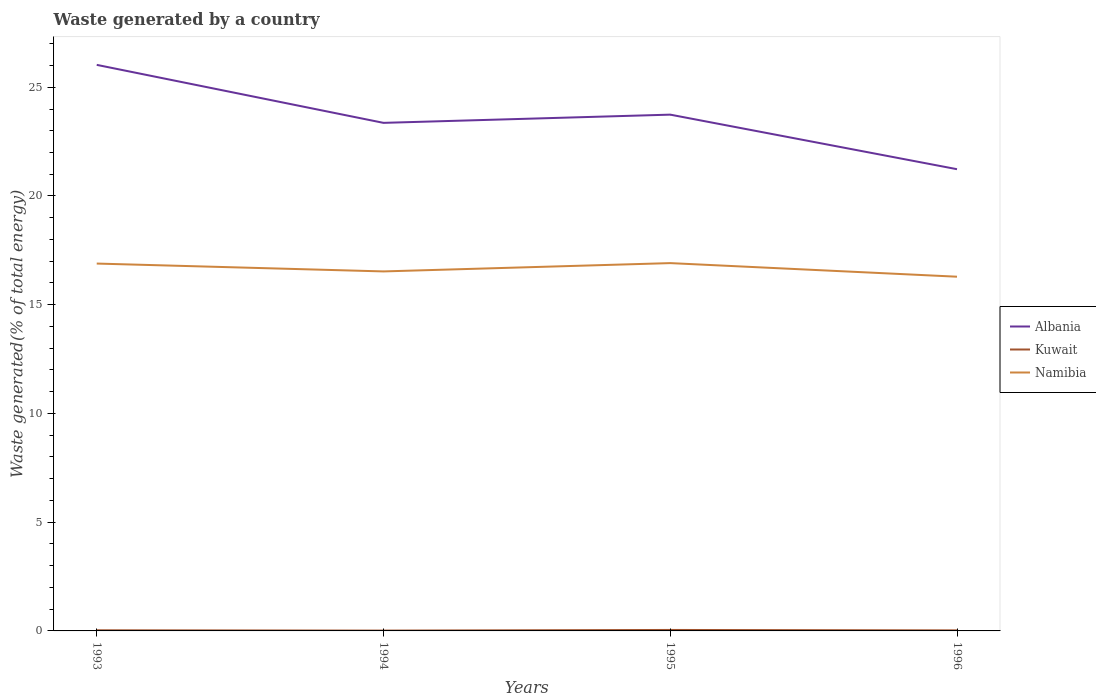How many different coloured lines are there?
Offer a very short reply. 3. Is the number of lines equal to the number of legend labels?
Make the answer very short. Yes. Across all years, what is the maximum total waste generated in Kuwait?
Ensure brevity in your answer.  0.02. What is the total total waste generated in Namibia in the graph?
Provide a succinct answer. 0.62. What is the difference between the highest and the second highest total waste generated in Albania?
Offer a very short reply. 4.8. Are the values on the major ticks of Y-axis written in scientific E-notation?
Provide a short and direct response. No. Does the graph contain any zero values?
Give a very brief answer. No. Does the graph contain grids?
Keep it short and to the point. No. Where does the legend appear in the graph?
Your response must be concise. Center right. How many legend labels are there?
Ensure brevity in your answer.  3. What is the title of the graph?
Keep it short and to the point. Waste generated by a country. What is the label or title of the Y-axis?
Give a very brief answer. Waste generated(% of total energy). What is the Waste generated(% of total energy) of Albania in 1993?
Provide a succinct answer. 26.03. What is the Waste generated(% of total energy) of Kuwait in 1993?
Make the answer very short. 0.03. What is the Waste generated(% of total energy) of Namibia in 1993?
Ensure brevity in your answer.  16.89. What is the Waste generated(% of total energy) of Albania in 1994?
Your response must be concise. 23.36. What is the Waste generated(% of total energy) in Kuwait in 1994?
Your answer should be very brief. 0.02. What is the Waste generated(% of total energy) in Namibia in 1994?
Keep it short and to the point. 16.53. What is the Waste generated(% of total energy) in Albania in 1995?
Offer a very short reply. 23.74. What is the Waste generated(% of total energy) in Kuwait in 1995?
Your answer should be very brief. 0.04. What is the Waste generated(% of total energy) in Namibia in 1995?
Keep it short and to the point. 16.91. What is the Waste generated(% of total energy) in Albania in 1996?
Offer a terse response. 21.23. What is the Waste generated(% of total energy) in Kuwait in 1996?
Your answer should be very brief. 0.03. What is the Waste generated(% of total energy) in Namibia in 1996?
Your response must be concise. 16.29. Across all years, what is the maximum Waste generated(% of total energy) in Albania?
Offer a very short reply. 26.03. Across all years, what is the maximum Waste generated(% of total energy) of Kuwait?
Provide a short and direct response. 0.04. Across all years, what is the maximum Waste generated(% of total energy) of Namibia?
Your answer should be compact. 16.91. Across all years, what is the minimum Waste generated(% of total energy) in Albania?
Offer a very short reply. 21.23. Across all years, what is the minimum Waste generated(% of total energy) in Kuwait?
Keep it short and to the point. 0.02. Across all years, what is the minimum Waste generated(% of total energy) of Namibia?
Make the answer very short. 16.29. What is the total Waste generated(% of total energy) of Albania in the graph?
Offer a very short reply. 94.37. What is the total Waste generated(% of total energy) in Kuwait in the graph?
Keep it short and to the point. 0.11. What is the total Waste generated(% of total energy) in Namibia in the graph?
Give a very brief answer. 66.63. What is the difference between the Waste generated(% of total energy) in Albania in 1993 and that in 1994?
Offer a very short reply. 2.67. What is the difference between the Waste generated(% of total energy) in Kuwait in 1993 and that in 1994?
Your answer should be very brief. 0.01. What is the difference between the Waste generated(% of total energy) in Namibia in 1993 and that in 1994?
Provide a succinct answer. 0.36. What is the difference between the Waste generated(% of total energy) in Albania in 1993 and that in 1995?
Provide a succinct answer. 2.29. What is the difference between the Waste generated(% of total energy) of Kuwait in 1993 and that in 1995?
Ensure brevity in your answer.  -0.01. What is the difference between the Waste generated(% of total energy) of Namibia in 1993 and that in 1995?
Give a very brief answer. -0.02. What is the difference between the Waste generated(% of total energy) in Albania in 1993 and that in 1996?
Provide a succinct answer. 4.8. What is the difference between the Waste generated(% of total energy) of Kuwait in 1993 and that in 1996?
Make the answer very short. 0. What is the difference between the Waste generated(% of total energy) of Namibia in 1993 and that in 1996?
Your response must be concise. 0.6. What is the difference between the Waste generated(% of total energy) of Albania in 1994 and that in 1995?
Give a very brief answer. -0.38. What is the difference between the Waste generated(% of total energy) in Kuwait in 1994 and that in 1995?
Offer a terse response. -0.03. What is the difference between the Waste generated(% of total energy) in Namibia in 1994 and that in 1995?
Ensure brevity in your answer.  -0.38. What is the difference between the Waste generated(% of total energy) in Albania in 1994 and that in 1996?
Provide a succinct answer. 2.13. What is the difference between the Waste generated(% of total energy) in Kuwait in 1994 and that in 1996?
Provide a short and direct response. -0.01. What is the difference between the Waste generated(% of total energy) of Namibia in 1994 and that in 1996?
Provide a short and direct response. 0.24. What is the difference between the Waste generated(% of total energy) in Albania in 1995 and that in 1996?
Give a very brief answer. 2.51. What is the difference between the Waste generated(% of total energy) in Kuwait in 1995 and that in 1996?
Your answer should be very brief. 0.02. What is the difference between the Waste generated(% of total energy) in Namibia in 1995 and that in 1996?
Offer a very short reply. 0.62. What is the difference between the Waste generated(% of total energy) of Albania in 1993 and the Waste generated(% of total energy) of Kuwait in 1994?
Give a very brief answer. 26.02. What is the difference between the Waste generated(% of total energy) of Albania in 1993 and the Waste generated(% of total energy) of Namibia in 1994?
Provide a succinct answer. 9.5. What is the difference between the Waste generated(% of total energy) of Kuwait in 1993 and the Waste generated(% of total energy) of Namibia in 1994?
Keep it short and to the point. -16.5. What is the difference between the Waste generated(% of total energy) of Albania in 1993 and the Waste generated(% of total energy) of Kuwait in 1995?
Make the answer very short. 25.99. What is the difference between the Waste generated(% of total energy) in Albania in 1993 and the Waste generated(% of total energy) in Namibia in 1995?
Ensure brevity in your answer.  9.12. What is the difference between the Waste generated(% of total energy) in Kuwait in 1993 and the Waste generated(% of total energy) in Namibia in 1995?
Your response must be concise. -16.88. What is the difference between the Waste generated(% of total energy) of Albania in 1993 and the Waste generated(% of total energy) of Kuwait in 1996?
Offer a very short reply. 26.01. What is the difference between the Waste generated(% of total energy) in Albania in 1993 and the Waste generated(% of total energy) in Namibia in 1996?
Your answer should be very brief. 9.74. What is the difference between the Waste generated(% of total energy) of Kuwait in 1993 and the Waste generated(% of total energy) of Namibia in 1996?
Ensure brevity in your answer.  -16.26. What is the difference between the Waste generated(% of total energy) in Albania in 1994 and the Waste generated(% of total energy) in Kuwait in 1995?
Make the answer very short. 23.32. What is the difference between the Waste generated(% of total energy) in Albania in 1994 and the Waste generated(% of total energy) in Namibia in 1995?
Ensure brevity in your answer.  6.45. What is the difference between the Waste generated(% of total energy) in Kuwait in 1994 and the Waste generated(% of total energy) in Namibia in 1995?
Make the answer very short. -16.9. What is the difference between the Waste generated(% of total energy) in Albania in 1994 and the Waste generated(% of total energy) in Kuwait in 1996?
Offer a terse response. 23.34. What is the difference between the Waste generated(% of total energy) in Albania in 1994 and the Waste generated(% of total energy) in Namibia in 1996?
Provide a short and direct response. 7.07. What is the difference between the Waste generated(% of total energy) in Kuwait in 1994 and the Waste generated(% of total energy) in Namibia in 1996?
Give a very brief answer. -16.27. What is the difference between the Waste generated(% of total energy) of Albania in 1995 and the Waste generated(% of total energy) of Kuwait in 1996?
Give a very brief answer. 23.72. What is the difference between the Waste generated(% of total energy) of Albania in 1995 and the Waste generated(% of total energy) of Namibia in 1996?
Provide a succinct answer. 7.45. What is the difference between the Waste generated(% of total energy) in Kuwait in 1995 and the Waste generated(% of total energy) in Namibia in 1996?
Your response must be concise. -16.24. What is the average Waste generated(% of total energy) of Albania per year?
Ensure brevity in your answer.  23.59. What is the average Waste generated(% of total energy) of Kuwait per year?
Keep it short and to the point. 0.03. What is the average Waste generated(% of total energy) of Namibia per year?
Provide a short and direct response. 16.66. In the year 1993, what is the difference between the Waste generated(% of total energy) of Albania and Waste generated(% of total energy) of Kuwait?
Offer a terse response. 26. In the year 1993, what is the difference between the Waste generated(% of total energy) in Albania and Waste generated(% of total energy) in Namibia?
Your answer should be very brief. 9.14. In the year 1993, what is the difference between the Waste generated(% of total energy) of Kuwait and Waste generated(% of total energy) of Namibia?
Give a very brief answer. -16.86. In the year 1994, what is the difference between the Waste generated(% of total energy) of Albania and Waste generated(% of total energy) of Kuwait?
Offer a terse response. 23.35. In the year 1994, what is the difference between the Waste generated(% of total energy) of Albania and Waste generated(% of total energy) of Namibia?
Your answer should be compact. 6.83. In the year 1994, what is the difference between the Waste generated(% of total energy) in Kuwait and Waste generated(% of total energy) in Namibia?
Your answer should be very brief. -16.52. In the year 1995, what is the difference between the Waste generated(% of total energy) in Albania and Waste generated(% of total energy) in Kuwait?
Provide a short and direct response. 23.7. In the year 1995, what is the difference between the Waste generated(% of total energy) in Albania and Waste generated(% of total energy) in Namibia?
Offer a very short reply. 6.83. In the year 1995, what is the difference between the Waste generated(% of total energy) of Kuwait and Waste generated(% of total energy) of Namibia?
Make the answer very short. -16.87. In the year 1996, what is the difference between the Waste generated(% of total energy) in Albania and Waste generated(% of total energy) in Kuwait?
Offer a terse response. 21.21. In the year 1996, what is the difference between the Waste generated(% of total energy) in Albania and Waste generated(% of total energy) in Namibia?
Provide a succinct answer. 4.94. In the year 1996, what is the difference between the Waste generated(% of total energy) in Kuwait and Waste generated(% of total energy) in Namibia?
Offer a terse response. -16.26. What is the ratio of the Waste generated(% of total energy) in Albania in 1993 to that in 1994?
Give a very brief answer. 1.11. What is the ratio of the Waste generated(% of total energy) of Kuwait in 1993 to that in 1994?
Keep it short and to the point. 1.95. What is the ratio of the Waste generated(% of total energy) of Namibia in 1993 to that in 1994?
Ensure brevity in your answer.  1.02. What is the ratio of the Waste generated(% of total energy) of Albania in 1993 to that in 1995?
Provide a succinct answer. 1.1. What is the ratio of the Waste generated(% of total energy) of Kuwait in 1993 to that in 1995?
Your response must be concise. 0.67. What is the ratio of the Waste generated(% of total energy) of Namibia in 1993 to that in 1995?
Offer a terse response. 1. What is the ratio of the Waste generated(% of total energy) of Albania in 1993 to that in 1996?
Offer a very short reply. 1.23. What is the ratio of the Waste generated(% of total energy) in Kuwait in 1993 to that in 1996?
Ensure brevity in your answer.  1.18. What is the ratio of the Waste generated(% of total energy) in Namibia in 1993 to that in 1996?
Your answer should be very brief. 1.04. What is the ratio of the Waste generated(% of total energy) of Albania in 1994 to that in 1995?
Ensure brevity in your answer.  0.98. What is the ratio of the Waste generated(% of total energy) in Kuwait in 1994 to that in 1995?
Offer a very short reply. 0.34. What is the ratio of the Waste generated(% of total energy) in Namibia in 1994 to that in 1995?
Give a very brief answer. 0.98. What is the ratio of the Waste generated(% of total energy) of Albania in 1994 to that in 1996?
Ensure brevity in your answer.  1.1. What is the ratio of the Waste generated(% of total energy) of Kuwait in 1994 to that in 1996?
Your answer should be compact. 0.61. What is the ratio of the Waste generated(% of total energy) of Namibia in 1994 to that in 1996?
Offer a terse response. 1.01. What is the ratio of the Waste generated(% of total energy) in Albania in 1995 to that in 1996?
Your answer should be compact. 1.12. What is the ratio of the Waste generated(% of total energy) in Kuwait in 1995 to that in 1996?
Offer a terse response. 1.77. What is the ratio of the Waste generated(% of total energy) in Namibia in 1995 to that in 1996?
Provide a short and direct response. 1.04. What is the difference between the highest and the second highest Waste generated(% of total energy) of Albania?
Keep it short and to the point. 2.29. What is the difference between the highest and the second highest Waste generated(% of total energy) in Kuwait?
Offer a terse response. 0.01. What is the difference between the highest and the second highest Waste generated(% of total energy) of Namibia?
Give a very brief answer. 0.02. What is the difference between the highest and the lowest Waste generated(% of total energy) in Albania?
Provide a short and direct response. 4.8. What is the difference between the highest and the lowest Waste generated(% of total energy) in Kuwait?
Make the answer very short. 0.03. What is the difference between the highest and the lowest Waste generated(% of total energy) in Namibia?
Ensure brevity in your answer.  0.62. 